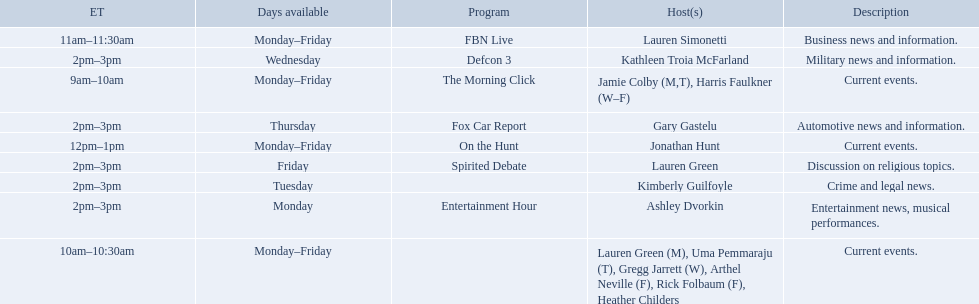Which programs broadcast by fox news channel hosts are listed? Jamie Colby (M,T), Harris Faulkner (W–F), Lauren Green (M), Uma Pemmaraju (T), Gregg Jarrett (W), Arthel Neville (F), Rick Folbaum (F), Heather Childers, Lauren Simonetti, Jonathan Hunt, Ashley Dvorkin, Kimberly Guilfoyle, Kathleen Troia McFarland, Gary Gastelu, Lauren Green. Of those, who have shows on friday? Jamie Colby (M,T), Harris Faulkner (W–F), Lauren Green (M), Uma Pemmaraju (T), Gregg Jarrett (W), Arthel Neville (F), Rick Folbaum (F), Heather Childers, Lauren Simonetti, Jonathan Hunt, Lauren Green. Of those, whose is at 2 pm? Lauren Green. 